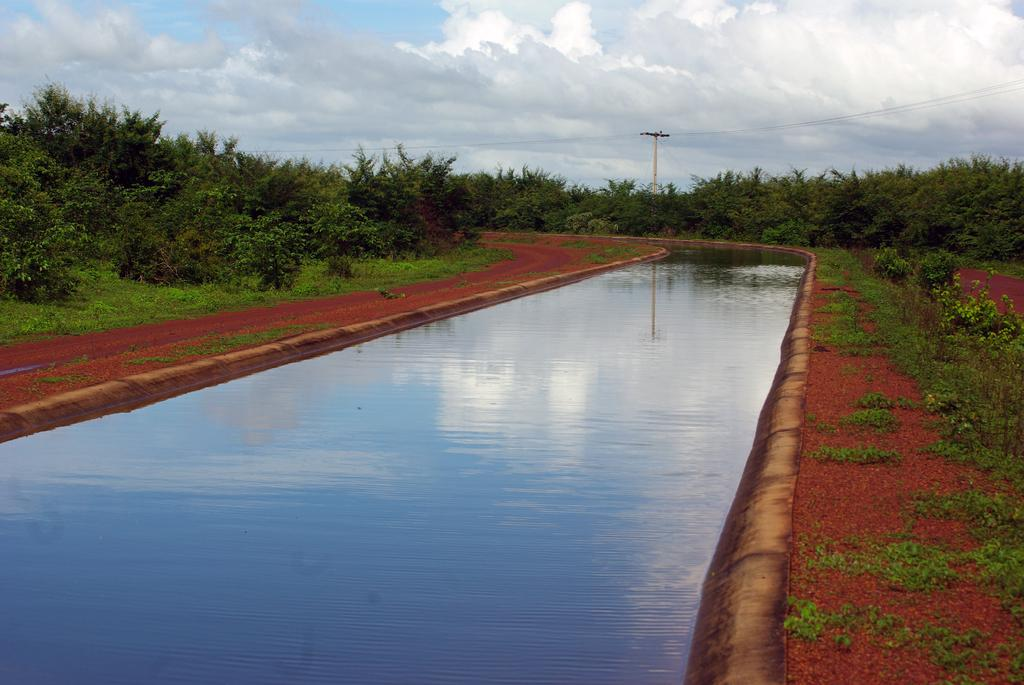What is the main subject in the center of the image? There is water in the center of the image. What can be seen in the background of the image? The sky, clouds, trees, plants, a pole, and grass are visible in the background of the image. Can you describe the sky in the image? The sky is visible in the background of the image. How many people are laughing in the crowd in the image? There is no crowd or people laughing in the image; it features water in the center and various elements in the background. 